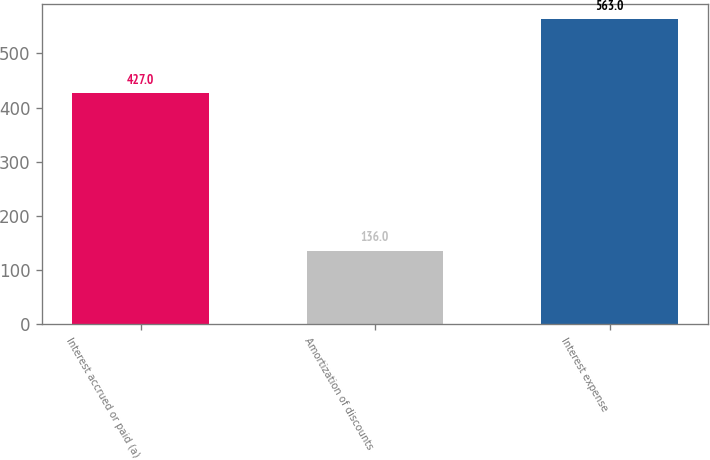Convert chart. <chart><loc_0><loc_0><loc_500><loc_500><bar_chart><fcel>Interest accrued or paid (a)<fcel>Amortization of discounts<fcel>Interest expense<nl><fcel>427<fcel>136<fcel>563<nl></chart> 